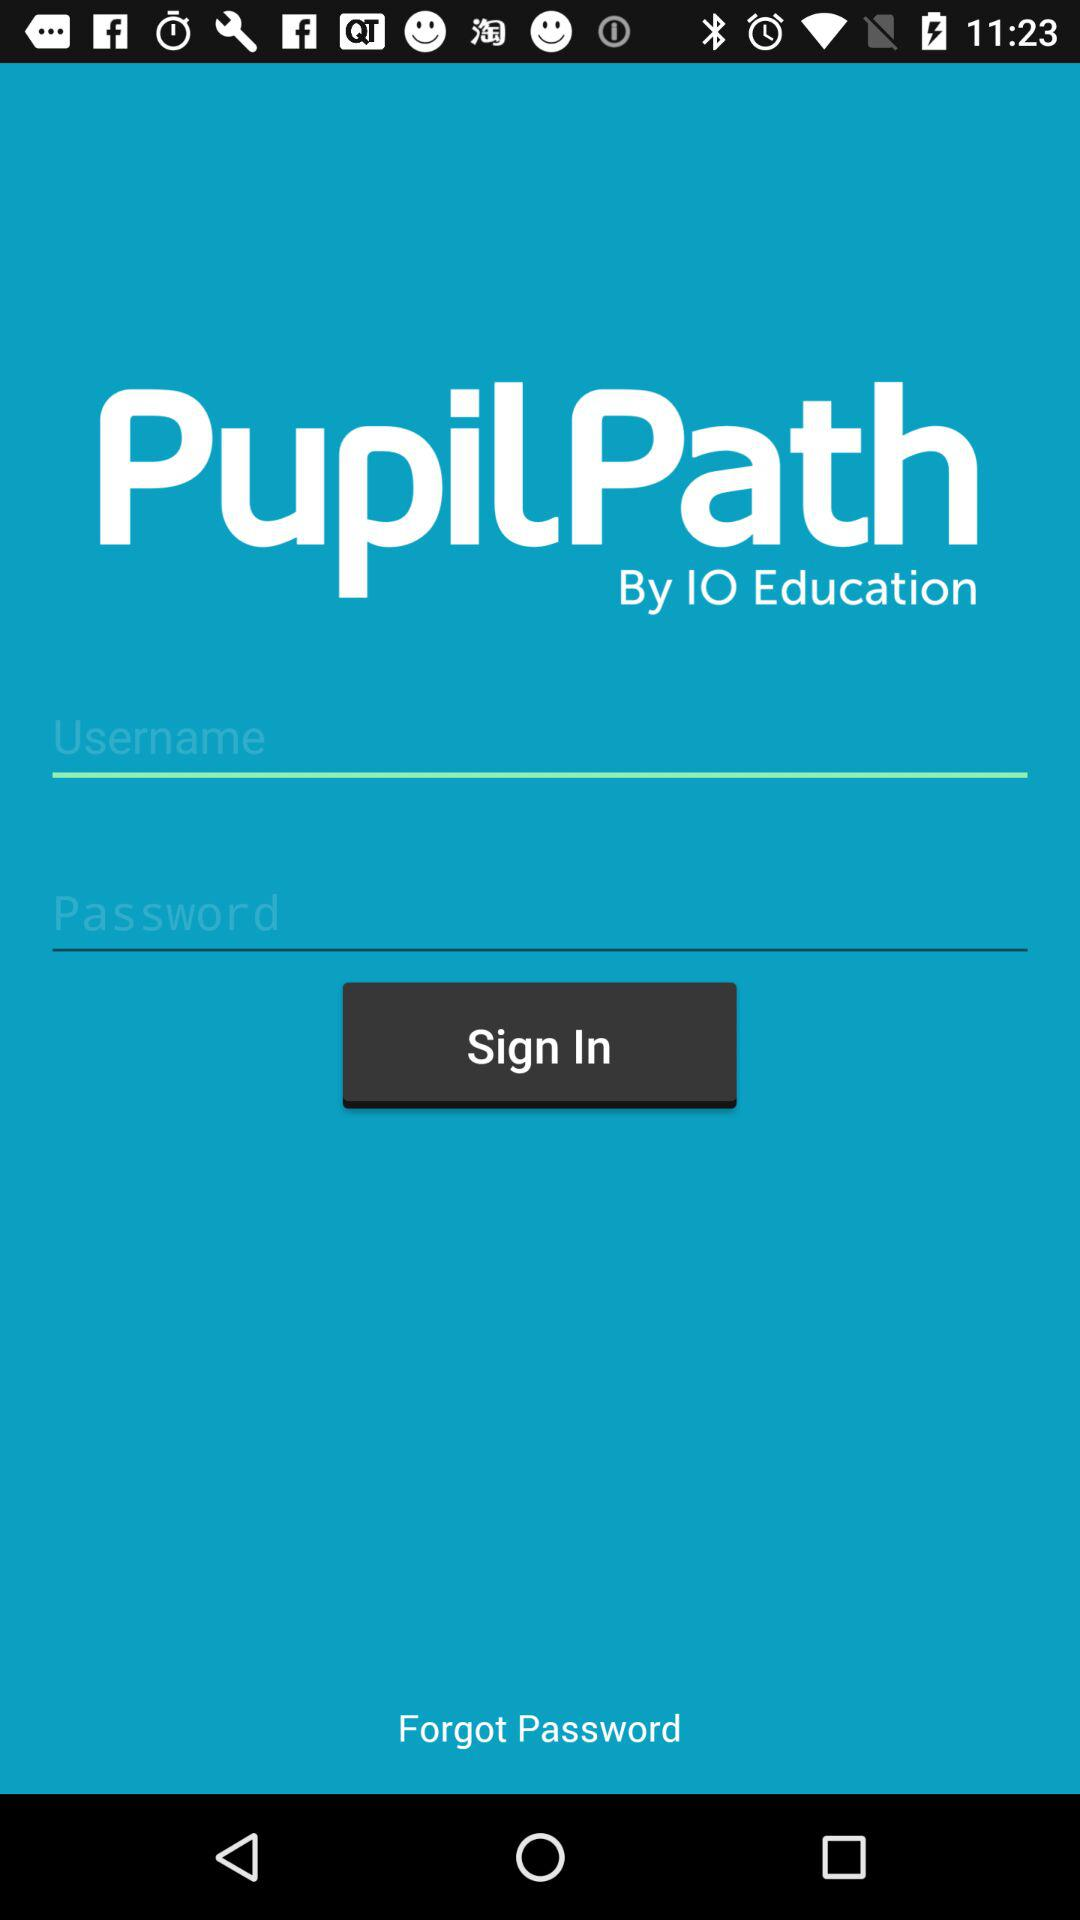What's the application name? The application name is "PupilPath". 